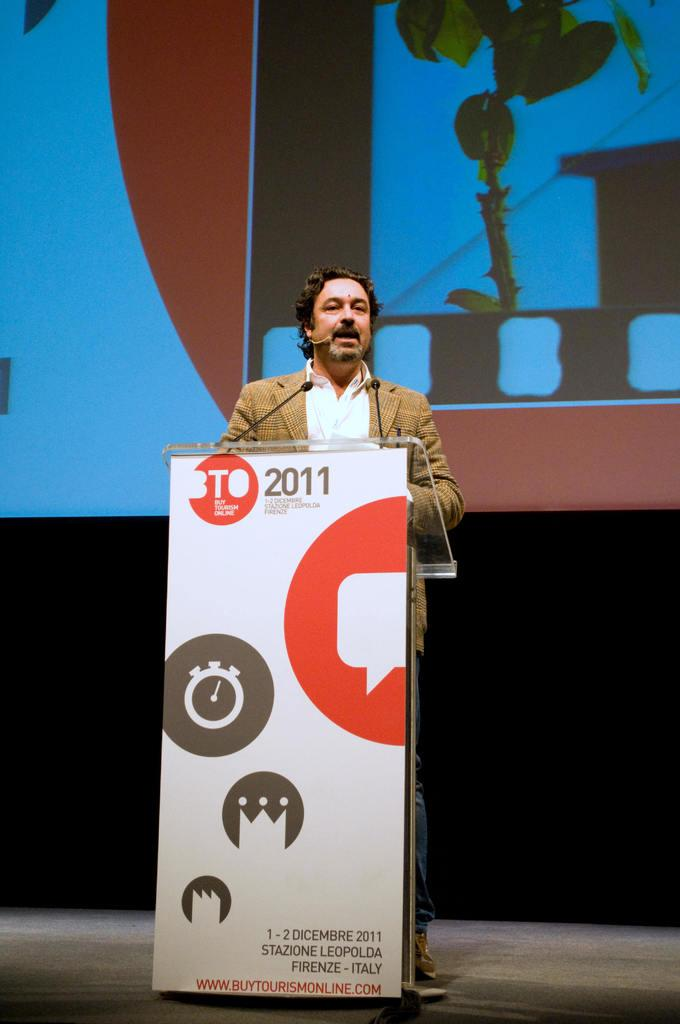<image>
Provide a brief description of the given image. A man speaking at a podium that has BTO 2011 on it. 